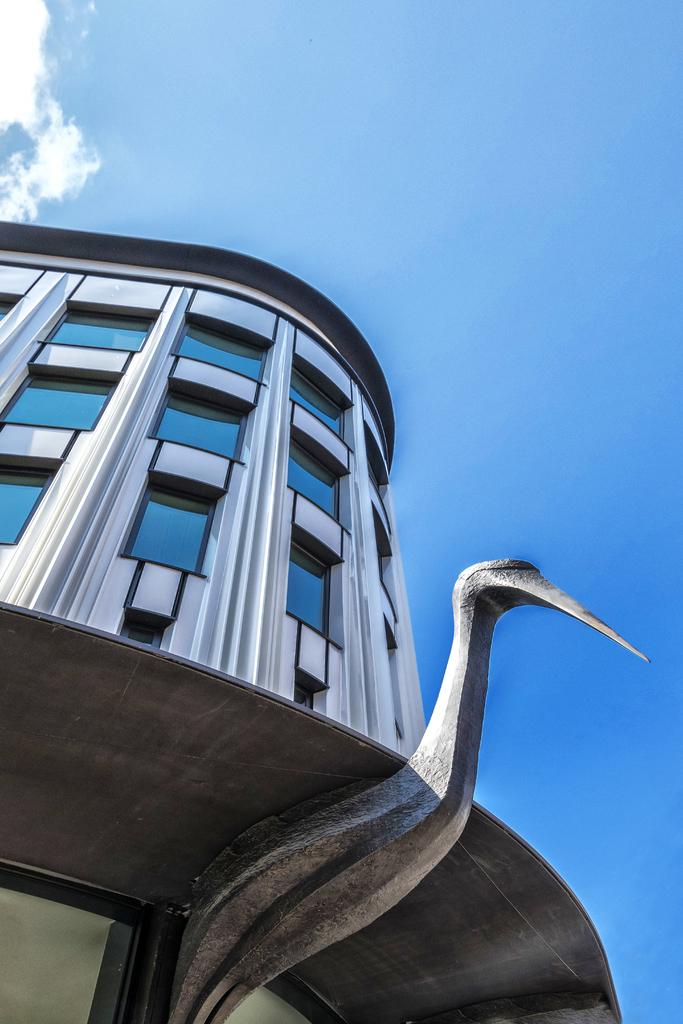What is located at the bottom of the image? There is a bird at the bottom of the image. What can be seen in the background of the image? There is a building in the background of the image. What feature of the building is mentioned in the facts? The building has windows. What is visible in the sky in the image? There are clouds in the sky. What type of pie is being smashed by the bird in the image? There is no pie present in the image, nor is the bird smashing anything. 